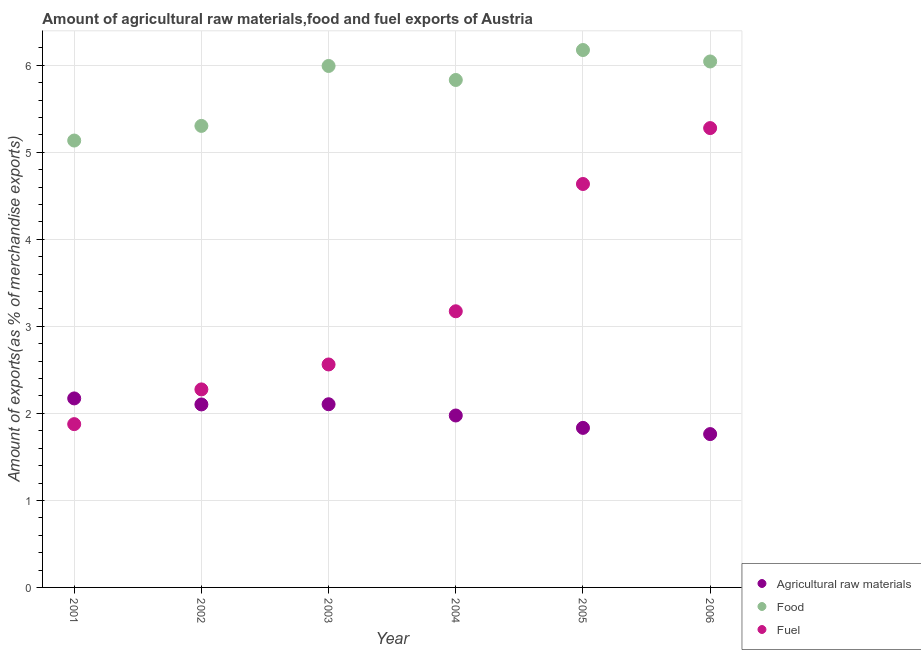Is the number of dotlines equal to the number of legend labels?
Keep it short and to the point. Yes. What is the percentage of fuel exports in 2002?
Your answer should be compact. 2.28. Across all years, what is the maximum percentage of fuel exports?
Keep it short and to the point. 5.28. Across all years, what is the minimum percentage of fuel exports?
Keep it short and to the point. 1.88. In which year was the percentage of raw materials exports maximum?
Ensure brevity in your answer.  2001. In which year was the percentage of fuel exports minimum?
Provide a succinct answer. 2001. What is the total percentage of food exports in the graph?
Your response must be concise. 34.48. What is the difference between the percentage of fuel exports in 2001 and that in 2003?
Your response must be concise. -0.69. What is the difference between the percentage of raw materials exports in 2005 and the percentage of food exports in 2004?
Provide a succinct answer. -4. What is the average percentage of fuel exports per year?
Offer a very short reply. 3.3. In the year 2003, what is the difference between the percentage of fuel exports and percentage of raw materials exports?
Make the answer very short. 0.46. In how many years, is the percentage of food exports greater than 0.4 %?
Ensure brevity in your answer.  6. What is the ratio of the percentage of raw materials exports in 2003 to that in 2004?
Offer a terse response. 1.07. What is the difference between the highest and the second highest percentage of raw materials exports?
Provide a short and direct response. 0.07. What is the difference between the highest and the lowest percentage of food exports?
Give a very brief answer. 1.04. Is it the case that in every year, the sum of the percentage of raw materials exports and percentage of food exports is greater than the percentage of fuel exports?
Your response must be concise. Yes. Is the percentage of food exports strictly greater than the percentage of fuel exports over the years?
Your answer should be very brief. Yes. How many dotlines are there?
Ensure brevity in your answer.  3. How many years are there in the graph?
Your answer should be very brief. 6. Are the values on the major ticks of Y-axis written in scientific E-notation?
Make the answer very short. No. Does the graph contain any zero values?
Ensure brevity in your answer.  No. Does the graph contain grids?
Provide a succinct answer. Yes. Where does the legend appear in the graph?
Make the answer very short. Bottom right. What is the title of the graph?
Offer a terse response. Amount of agricultural raw materials,food and fuel exports of Austria. What is the label or title of the X-axis?
Your answer should be very brief. Year. What is the label or title of the Y-axis?
Ensure brevity in your answer.  Amount of exports(as % of merchandise exports). What is the Amount of exports(as % of merchandise exports) in Agricultural raw materials in 2001?
Your answer should be very brief. 2.17. What is the Amount of exports(as % of merchandise exports) in Food in 2001?
Offer a very short reply. 5.14. What is the Amount of exports(as % of merchandise exports) in Fuel in 2001?
Your answer should be compact. 1.88. What is the Amount of exports(as % of merchandise exports) of Agricultural raw materials in 2002?
Offer a terse response. 2.1. What is the Amount of exports(as % of merchandise exports) of Food in 2002?
Your answer should be compact. 5.3. What is the Amount of exports(as % of merchandise exports) in Fuel in 2002?
Provide a succinct answer. 2.28. What is the Amount of exports(as % of merchandise exports) of Agricultural raw materials in 2003?
Your answer should be very brief. 2.11. What is the Amount of exports(as % of merchandise exports) in Food in 2003?
Provide a short and direct response. 5.99. What is the Amount of exports(as % of merchandise exports) in Fuel in 2003?
Ensure brevity in your answer.  2.56. What is the Amount of exports(as % of merchandise exports) in Agricultural raw materials in 2004?
Your answer should be very brief. 1.98. What is the Amount of exports(as % of merchandise exports) in Food in 2004?
Your answer should be very brief. 5.83. What is the Amount of exports(as % of merchandise exports) of Fuel in 2004?
Offer a very short reply. 3.17. What is the Amount of exports(as % of merchandise exports) of Agricultural raw materials in 2005?
Offer a very short reply. 1.83. What is the Amount of exports(as % of merchandise exports) in Food in 2005?
Your answer should be very brief. 6.18. What is the Amount of exports(as % of merchandise exports) of Fuel in 2005?
Provide a short and direct response. 4.64. What is the Amount of exports(as % of merchandise exports) of Agricultural raw materials in 2006?
Offer a terse response. 1.76. What is the Amount of exports(as % of merchandise exports) in Food in 2006?
Provide a short and direct response. 6.04. What is the Amount of exports(as % of merchandise exports) in Fuel in 2006?
Offer a very short reply. 5.28. Across all years, what is the maximum Amount of exports(as % of merchandise exports) in Agricultural raw materials?
Ensure brevity in your answer.  2.17. Across all years, what is the maximum Amount of exports(as % of merchandise exports) in Food?
Give a very brief answer. 6.18. Across all years, what is the maximum Amount of exports(as % of merchandise exports) of Fuel?
Ensure brevity in your answer.  5.28. Across all years, what is the minimum Amount of exports(as % of merchandise exports) of Agricultural raw materials?
Your response must be concise. 1.76. Across all years, what is the minimum Amount of exports(as % of merchandise exports) in Food?
Provide a succinct answer. 5.14. Across all years, what is the minimum Amount of exports(as % of merchandise exports) in Fuel?
Ensure brevity in your answer.  1.88. What is the total Amount of exports(as % of merchandise exports) of Agricultural raw materials in the graph?
Offer a terse response. 11.95. What is the total Amount of exports(as % of merchandise exports) of Food in the graph?
Ensure brevity in your answer.  34.48. What is the total Amount of exports(as % of merchandise exports) of Fuel in the graph?
Offer a very short reply. 19.8. What is the difference between the Amount of exports(as % of merchandise exports) in Agricultural raw materials in 2001 and that in 2002?
Your answer should be very brief. 0.07. What is the difference between the Amount of exports(as % of merchandise exports) in Food in 2001 and that in 2002?
Provide a succinct answer. -0.17. What is the difference between the Amount of exports(as % of merchandise exports) of Fuel in 2001 and that in 2002?
Provide a succinct answer. -0.4. What is the difference between the Amount of exports(as % of merchandise exports) in Agricultural raw materials in 2001 and that in 2003?
Provide a succinct answer. 0.07. What is the difference between the Amount of exports(as % of merchandise exports) in Food in 2001 and that in 2003?
Your answer should be very brief. -0.86. What is the difference between the Amount of exports(as % of merchandise exports) of Fuel in 2001 and that in 2003?
Your response must be concise. -0.69. What is the difference between the Amount of exports(as % of merchandise exports) of Agricultural raw materials in 2001 and that in 2004?
Give a very brief answer. 0.2. What is the difference between the Amount of exports(as % of merchandise exports) of Food in 2001 and that in 2004?
Offer a very short reply. -0.7. What is the difference between the Amount of exports(as % of merchandise exports) in Fuel in 2001 and that in 2004?
Your answer should be compact. -1.3. What is the difference between the Amount of exports(as % of merchandise exports) in Agricultural raw materials in 2001 and that in 2005?
Your answer should be very brief. 0.34. What is the difference between the Amount of exports(as % of merchandise exports) of Food in 2001 and that in 2005?
Make the answer very short. -1.04. What is the difference between the Amount of exports(as % of merchandise exports) in Fuel in 2001 and that in 2005?
Offer a very short reply. -2.76. What is the difference between the Amount of exports(as % of merchandise exports) in Agricultural raw materials in 2001 and that in 2006?
Keep it short and to the point. 0.41. What is the difference between the Amount of exports(as % of merchandise exports) of Food in 2001 and that in 2006?
Your answer should be very brief. -0.91. What is the difference between the Amount of exports(as % of merchandise exports) in Fuel in 2001 and that in 2006?
Provide a short and direct response. -3.4. What is the difference between the Amount of exports(as % of merchandise exports) of Agricultural raw materials in 2002 and that in 2003?
Provide a succinct answer. -0. What is the difference between the Amount of exports(as % of merchandise exports) in Food in 2002 and that in 2003?
Make the answer very short. -0.69. What is the difference between the Amount of exports(as % of merchandise exports) in Fuel in 2002 and that in 2003?
Offer a terse response. -0.29. What is the difference between the Amount of exports(as % of merchandise exports) of Agricultural raw materials in 2002 and that in 2004?
Keep it short and to the point. 0.13. What is the difference between the Amount of exports(as % of merchandise exports) in Food in 2002 and that in 2004?
Provide a succinct answer. -0.53. What is the difference between the Amount of exports(as % of merchandise exports) of Fuel in 2002 and that in 2004?
Ensure brevity in your answer.  -0.9. What is the difference between the Amount of exports(as % of merchandise exports) in Agricultural raw materials in 2002 and that in 2005?
Give a very brief answer. 0.27. What is the difference between the Amount of exports(as % of merchandise exports) in Food in 2002 and that in 2005?
Your answer should be compact. -0.87. What is the difference between the Amount of exports(as % of merchandise exports) in Fuel in 2002 and that in 2005?
Your response must be concise. -2.36. What is the difference between the Amount of exports(as % of merchandise exports) in Agricultural raw materials in 2002 and that in 2006?
Your answer should be very brief. 0.34. What is the difference between the Amount of exports(as % of merchandise exports) in Food in 2002 and that in 2006?
Your answer should be very brief. -0.74. What is the difference between the Amount of exports(as % of merchandise exports) of Fuel in 2002 and that in 2006?
Provide a succinct answer. -3. What is the difference between the Amount of exports(as % of merchandise exports) of Agricultural raw materials in 2003 and that in 2004?
Offer a very short reply. 0.13. What is the difference between the Amount of exports(as % of merchandise exports) of Food in 2003 and that in 2004?
Offer a terse response. 0.16. What is the difference between the Amount of exports(as % of merchandise exports) of Fuel in 2003 and that in 2004?
Offer a terse response. -0.61. What is the difference between the Amount of exports(as % of merchandise exports) of Agricultural raw materials in 2003 and that in 2005?
Ensure brevity in your answer.  0.27. What is the difference between the Amount of exports(as % of merchandise exports) in Food in 2003 and that in 2005?
Your response must be concise. -0.18. What is the difference between the Amount of exports(as % of merchandise exports) in Fuel in 2003 and that in 2005?
Keep it short and to the point. -2.07. What is the difference between the Amount of exports(as % of merchandise exports) in Agricultural raw materials in 2003 and that in 2006?
Provide a succinct answer. 0.34. What is the difference between the Amount of exports(as % of merchandise exports) of Food in 2003 and that in 2006?
Keep it short and to the point. -0.05. What is the difference between the Amount of exports(as % of merchandise exports) of Fuel in 2003 and that in 2006?
Keep it short and to the point. -2.72. What is the difference between the Amount of exports(as % of merchandise exports) in Agricultural raw materials in 2004 and that in 2005?
Make the answer very short. 0.14. What is the difference between the Amount of exports(as % of merchandise exports) in Food in 2004 and that in 2005?
Your response must be concise. -0.34. What is the difference between the Amount of exports(as % of merchandise exports) in Fuel in 2004 and that in 2005?
Ensure brevity in your answer.  -1.46. What is the difference between the Amount of exports(as % of merchandise exports) in Agricultural raw materials in 2004 and that in 2006?
Your answer should be very brief. 0.21. What is the difference between the Amount of exports(as % of merchandise exports) in Food in 2004 and that in 2006?
Provide a succinct answer. -0.21. What is the difference between the Amount of exports(as % of merchandise exports) of Fuel in 2004 and that in 2006?
Your answer should be very brief. -2.11. What is the difference between the Amount of exports(as % of merchandise exports) of Agricultural raw materials in 2005 and that in 2006?
Provide a short and direct response. 0.07. What is the difference between the Amount of exports(as % of merchandise exports) of Food in 2005 and that in 2006?
Keep it short and to the point. 0.13. What is the difference between the Amount of exports(as % of merchandise exports) in Fuel in 2005 and that in 2006?
Offer a terse response. -0.64. What is the difference between the Amount of exports(as % of merchandise exports) of Agricultural raw materials in 2001 and the Amount of exports(as % of merchandise exports) of Food in 2002?
Provide a short and direct response. -3.13. What is the difference between the Amount of exports(as % of merchandise exports) in Agricultural raw materials in 2001 and the Amount of exports(as % of merchandise exports) in Fuel in 2002?
Offer a very short reply. -0.1. What is the difference between the Amount of exports(as % of merchandise exports) of Food in 2001 and the Amount of exports(as % of merchandise exports) of Fuel in 2002?
Your answer should be very brief. 2.86. What is the difference between the Amount of exports(as % of merchandise exports) of Agricultural raw materials in 2001 and the Amount of exports(as % of merchandise exports) of Food in 2003?
Make the answer very short. -3.82. What is the difference between the Amount of exports(as % of merchandise exports) in Agricultural raw materials in 2001 and the Amount of exports(as % of merchandise exports) in Fuel in 2003?
Keep it short and to the point. -0.39. What is the difference between the Amount of exports(as % of merchandise exports) of Food in 2001 and the Amount of exports(as % of merchandise exports) of Fuel in 2003?
Provide a succinct answer. 2.57. What is the difference between the Amount of exports(as % of merchandise exports) of Agricultural raw materials in 2001 and the Amount of exports(as % of merchandise exports) of Food in 2004?
Offer a terse response. -3.66. What is the difference between the Amount of exports(as % of merchandise exports) in Agricultural raw materials in 2001 and the Amount of exports(as % of merchandise exports) in Fuel in 2004?
Provide a short and direct response. -1. What is the difference between the Amount of exports(as % of merchandise exports) of Food in 2001 and the Amount of exports(as % of merchandise exports) of Fuel in 2004?
Give a very brief answer. 1.96. What is the difference between the Amount of exports(as % of merchandise exports) of Agricultural raw materials in 2001 and the Amount of exports(as % of merchandise exports) of Food in 2005?
Your answer should be very brief. -4. What is the difference between the Amount of exports(as % of merchandise exports) in Agricultural raw materials in 2001 and the Amount of exports(as % of merchandise exports) in Fuel in 2005?
Give a very brief answer. -2.46. What is the difference between the Amount of exports(as % of merchandise exports) of Food in 2001 and the Amount of exports(as % of merchandise exports) of Fuel in 2005?
Your answer should be compact. 0.5. What is the difference between the Amount of exports(as % of merchandise exports) of Agricultural raw materials in 2001 and the Amount of exports(as % of merchandise exports) of Food in 2006?
Your answer should be compact. -3.87. What is the difference between the Amount of exports(as % of merchandise exports) of Agricultural raw materials in 2001 and the Amount of exports(as % of merchandise exports) of Fuel in 2006?
Provide a succinct answer. -3.11. What is the difference between the Amount of exports(as % of merchandise exports) of Food in 2001 and the Amount of exports(as % of merchandise exports) of Fuel in 2006?
Offer a terse response. -0.14. What is the difference between the Amount of exports(as % of merchandise exports) of Agricultural raw materials in 2002 and the Amount of exports(as % of merchandise exports) of Food in 2003?
Your response must be concise. -3.89. What is the difference between the Amount of exports(as % of merchandise exports) in Agricultural raw materials in 2002 and the Amount of exports(as % of merchandise exports) in Fuel in 2003?
Provide a succinct answer. -0.46. What is the difference between the Amount of exports(as % of merchandise exports) in Food in 2002 and the Amount of exports(as % of merchandise exports) in Fuel in 2003?
Ensure brevity in your answer.  2.74. What is the difference between the Amount of exports(as % of merchandise exports) of Agricultural raw materials in 2002 and the Amount of exports(as % of merchandise exports) of Food in 2004?
Offer a very short reply. -3.73. What is the difference between the Amount of exports(as % of merchandise exports) of Agricultural raw materials in 2002 and the Amount of exports(as % of merchandise exports) of Fuel in 2004?
Offer a very short reply. -1.07. What is the difference between the Amount of exports(as % of merchandise exports) of Food in 2002 and the Amount of exports(as % of merchandise exports) of Fuel in 2004?
Keep it short and to the point. 2.13. What is the difference between the Amount of exports(as % of merchandise exports) in Agricultural raw materials in 2002 and the Amount of exports(as % of merchandise exports) in Food in 2005?
Ensure brevity in your answer.  -4.07. What is the difference between the Amount of exports(as % of merchandise exports) of Agricultural raw materials in 2002 and the Amount of exports(as % of merchandise exports) of Fuel in 2005?
Ensure brevity in your answer.  -2.53. What is the difference between the Amount of exports(as % of merchandise exports) of Food in 2002 and the Amount of exports(as % of merchandise exports) of Fuel in 2005?
Offer a terse response. 0.67. What is the difference between the Amount of exports(as % of merchandise exports) of Agricultural raw materials in 2002 and the Amount of exports(as % of merchandise exports) of Food in 2006?
Provide a succinct answer. -3.94. What is the difference between the Amount of exports(as % of merchandise exports) of Agricultural raw materials in 2002 and the Amount of exports(as % of merchandise exports) of Fuel in 2006?
Provide a short and direct response. -3.18. What is the difference between the Amount of exports(as % of merchandise exports) of Food in 2002 and the Amount of exports(as % of merchandise exports) of Fuel in 2006?
Offer a very short reply. 0.03. What is the difference between the Amount of exports(as % of merchandise exports) in Agricultural raw materials in 2003 and the Amount of exports(as % of merchandise exports) in Food in 2004?
Make the answer very short. -3.73. What is the difference between the Amount of exports(as % of merchandise exports) of Agricultural raw materials in 2003 and the Amount of exports(as % of merchandise exports) of Fuel in 2004?
Your answer should be compact. -1.07. What is the difference between the Amount of exports(as % of merchandise exports) of Food in 2003 and the Amount of exports(as % of merchandise exports) of Fuel in 2004?
Ensure brevity in your answer.  2.82. What is the difference between the Amount of exports(as % of merchandise exports) of Agricultural raw materials in 2003 and the Amount of exports(as % of merchandise exports) of Food in 2005?
Keep it short and to the point. -4.07. What is the difference between the Amount of exports(as % of merchandise exports) of Agricultural raw materials in 2003 and the Amount of exports(as % of merchandise exports) of Fuel in 2005?
Your answer should be compact. -2.53. What is the difference between the Amount of exports(as % of merchandise exports) of Food in 2003 and the Amount of exports(as % of merchandise exports) of Fuel in 2005?
Your answer should be compact. 1.36. What is the difference between the Amount of exports(as % of merchandise exports) in Agricultural raw materials in 2003 and the Amount of exports(as % of merchandise exports) in Food in 2006?
Provide a short and direct response. -3.94. What is the difference between the Amount of exports(as % of merchandise exports) of Agricultural raw materials in 2003 and the Amount of exports(as % of merchandise exports) of Fuel in 2006?
Your answer should be very brief. -3.17. What is the difference between the Amount of exports(as % of merchandise exports) in Food in 2003 and the Amount of exports(as % of merchandise exports) in Fuel in 2006?
Your answer should be very brief. 0.71. What is the difference between the Amount of exports(as % of merchandise exports) in Agricultural raw materials in 2004 and the Amount of exports(as % of merchandise exports) in Food in 2005?
Your response must be concise. -4.2. What is the difference between the Amount of exports(as % of merchandise exports) in Agricultural raw materials in 2004 and the Amount of exports(as % of merchandise exports) in Fuel in 2005?
Provide a short and direct response. -2.66. What is the difference between the Amount of exports(as % of merchandise exports) in Food in 2004 and the Amount of exports(as % of merchandise exports) in Fuel in 2005?
Make the answer very short. 1.2. What is the difference between the Amount of exports(as % of merchandise exports) of Agricultural raw materials in 2004 and the Amount of exports(as % of merchandise exports) of Food in 2006?
Make the answer very short. -4.07. What is the difference between the Amount of exports(as % of merchandise exports) of Agricultural raw materials in 2004 and the Amount of exports(as % of merchandise exports) of Fuel in 2006?
Ensure brevity in your answer.  -3.3. What is the difference between the Amount of exports(as % of merchandise exports) of Food in 2004 and the Amount of exports(as % of merchandise exports) of Fuel in 2006?
Give a very brief answer. 0.55. What is the difference between the Amount of exports(as % of merchandise exports) of Agricultural raw materials in 2005 and the Amount of exports(as % of merchandise exports) of Food in 2006?
Give a very brief answer. -4.21. What is the difference between the Amount of exports(as % of merchandise exports) in Agricultural raw materials in 2005 and the Amount of exports(as % of merchandise exports) in Fuel in 2006?
Give a very brief answer. -3.45. What is the difference between the Amount of exports(as % of merchandise exports) of Food in 2005 and the Amount of exports(as % of merchandise exports) of Fuel in 2006?
Give a very brief answer. 0.9. What is the average Amount of exports(as % of merchandise exports) of Agricultural raw materials per year?
Offer a very short reply. 1.99. What is the average Amount of exports(as % of merchandise exports) of Food per year?
Your answer should be compact. 5.75. What is the average Amount of exports(as % of merchandise exports) in Fuel per year?
Offer a very short reply. 3.3. In the year 2001, what is the difference between the Amount of exports(as % of merchandise exports) of Agricultural raw materials and Amount of exports(as % of merchandise exports) of Food?
Make the answer very short. -2.96. In the year 2001, what is the difference between the Amount of exports(as % of merchandise exports) in Agricultural raw materials and Amount of exports(as % of merchandise exports) in Fuel?
Your answer should be compact. 0.3. In the year 2001, what is the difference between the Amount of exports(as % of merchandise exports) in Food and Amount of exports(as % of merchandise exports) in Fuel?
Your answer should be compact. 3.26. In the year 2002, what is the difference between the Amount of exports(as % of merchandise exports) of Agricultural raw materials and Amount of exports(as % of merchandise exports) of Food?
Provide a succinct answer. -3.2. In the year 2002, what is the difference between the Amount of exports(as % of merchandise exports) in Agricultural raw materials and Amount of exports(as % of merchandise exports) in Fuel?
Give a very brief answer. -0.17. In the year 2002, what is the difference between the Amount of exports(as % of merchandise exports) of Food and Amount of exports(as % of merchandise exports) of Fuel?
Make the answer very short. 3.03. In the year 2003, what is the difference between the Amount of exports(as % of merchandise exports) of Agricultural raw materials and Amount of exports(as % of merchandise exports) of Food?
Offer a terse response. -3.89. In the year 2003, what is the difference between the Amount of exports(as % of merchandise exports) in Agricultural raw materials and Amount of exports(as % of merchandise exports) in Fuel?
Keep it short and to the point. -0.46. In the year 2003, what is the difference between the Amount of exports(as % of merchandise exports) of Food and Amount of exports(as % of merchandise exports) of Fuel?
Provide a short and direct response. 3.43. In the year 2004, what is the difference between the Amount of exports(as % of merchandise exports) in Agricultural raw materials and Amount of exports(as % of merchandise exports) in Food?
Ensure brevity in your answer.  -3.86. In the year 2004, what is the difference between the Amount of exports(as % of merchandise exports) of Agricultural raw materials and Amount of exports(as % of merchandise exports) of Fuel?
Your response must be concise. -1.2. In the year 2004, what is the difference between the Amount of exports(as % of merchandise exports) in Food and Amount of exports(as % of merchandise exports) in Fuel?
Your answer should be very brief. 2.66. In the year 2005, what is the difference between the Amount of exports(as % of merchandise exports) in Agricultural raw materials and Amount of exports(as % of merchandise exports) in Food?
Provide a succinct answer. -4.34. In the year 2005, what is the difference between the Amount of exports(as % of merchandise exports) of Agricultural raw materials and Amount of exports(as % of merchandise exports) of Fuel?
Your answer should be very brief. -2.8. In the year 2005, what is the difference between the Amount of exports(as % of merchandise exports) in Food and Amount of exports(as % of merchandise exports) in Fuel?
Ensure brevity in your answer.  1.54. In the year 2006, what is the difference between the Amount of exports(as % of merchandise exports) in Agricultural raw materials and Amount of exports(as % of merchandise exports) in Food?
Ensure brevity in your answer.  -4.28. In the year 2006, what is the difference between the Amount of exports(as % of merchandise exports) of Agricultural raw materials and Amount of exports(as % of merchandise exports) of Fuel?
Make the answer very short. -3.52. In the year 2006, what is the difference between the Amount of exports(as % of merchandise exports) of Food and Amount of exports(as % of merchandise exports) of Fuel?
Your response must be concise. 0.77. What is the ratio of the Amount of exports(as % of merchandise exports) of Agricultural raw materials in 2001 to that in 2002?
Offer a very short reply. 1.03. What is the ratio of the Amount of exports(as % of merchandise exports) in Food in 2001 to that in 2002?
Your answer should be compact. 0.97. What is the ratio of the Amount of exports(as % of merchandise exports) in Fuel in 2001 to that in 2002?
Your answer should be very brief. 0.82. What is the ratio of the Amount of exports(as % of merchandise exports) of Agricultural raw materials in 2001 to that in 2003?
Your answer should be very brief. 1.03. What is the ratio of the Amount of exports(as % of merchandise exports) in Food in 2001 to that in 2003?
Provide a succinct answer. 0.86. What is the ratio of the Amount of exports(as % of merchandise exports) in Fuel in 2001 to that in 2003?
Make the answer very short. 0.73. What is the ratio of the Amount of exports(as % of merchandise exports) in Agricultural raw materials in 2001 to that in 2004?
Ensure brevity in your answer.  1.1. What is the ratio of the Amount of exports(as % of merchandise exports) of Food in 2001 to that in 2004?
Provide a short and direct response. 0.88. What is the ratio of the Amount of exports(as % of merchandise exports) in Fuel in 2001 to that in 2004?
Offer a terse response. 0.59. What is the ratio of the Amount of exports(as % of merchandise exports) of Agricultural raw materials in 2001 to that in 2005?
Offer a very short reply. 1.18. What is the ratio of the Amount of exports(as % of merchandise exports) of Food in 2001 to that in 2005?
Offer a terse response. 0.83. What is the ratio of the Amount of exports(as % of merchandise exports) in Fuel in 2001 to that in 2005?
Your response must be concise. 0.4. What is the ratio of the Amount of exports(as % of merchandise exports) in Agricultural raw materials in 2001 to that in 2006?
Your answer should be very brief. 1.23. What is the ratio of the Amount of exports(as % of merchandise exports) of Food in 2001 to that in 2006?
Your answer should be very brief. 0.85. What is the ratio of the Amount of exports(as % of merchandise exports) in Fuel in 2001 to that in 2006?
Your answer should be compact. 0.36. What is the ratio of the Amount of exports(as % of merchandise exports) of Food in 2002 to that in 2003?
Your answer should be very brief. 0.89. What is the ratio of the Amount of exports(as % of merchandise exports) in Fuel in 2002 to that in 2003?
Your answer should be compact. 0.89. What is the ratio of the Amount of exports(as % of merchandise exports) in Agricultural raw materials in 2002 to that in 2004?
Offer a terse response. 1.06. What is the ratio of the Amount of exports(as % of merchandise exports) of Food in 2002 to that in 2004?
Provide a short and direct response. 0.91. What is the ratio of the Amount of exports(as % of merchandise exports) in Fuel in 2002 to that in 2004?
Your response must be concise. 0.72. What is the ratio of the Amount of exports(as % of merchandise exports) of Agricultural raw materials in 2002 to that in 2005?
Your response must be concise. 1.15. What is the ratio of the Amount of exports(as % of merchandise exports) of Food in 2002 to that in 2005?
Your answer should be compact. 0.86. What is the ratio of the Amount of exports(as % of merchandise exports) in Fuel in 2002 to that in 2005?
Offer a terse response. 0.49. What is the ratio of the Amount of exports(as % of merchandise exports) of Agricultural raw materials in 2002 to that in 2006?
Provide a short and direct response. 1.19. What is the ratio of the Amount of exports(as % of merchandise exports) of Food in 2002 to that in 2006?
Give a very brief answer. 0.88. What is the ratio of the Amount of exports(as % of merchandise exports) of Fuel in 2002 to that in 2006?
Offer a terse response. 0.43. What is the ratio of the Amount of exports(as % of merchandise exports) of Agricultural raw materials in 2003 to that in 2004?
Give a very brief answer. 1.07. What is the ratio of the Amount of exports(as % of merchandise exports) in Food in 2003 to that in 2004?
Your answer should be very brief. 1.03. What is the ratio of the Amount of exports(as % of merchandise exports) in Fuel in 2003 to that in 2004?
Offer a very short reply. 0.81. What is the ratio of the Amount of exports(as % of merchandise exports) of Agricultural raw materials in 2003 to that in 2005?
Provide a succinct answer. 1.15. What is the ratio of the Amount of exports(as % of merchandise exports) in Food in 2003 to that in 2005?
Give a very brief answer. 0.97. What is the ratio of the Amount of exports(as % of merchandise exports) of Fuel in 2003 to that in 2005?
Offer a terse response. 0.55. What is the ratio of the Amount of exports(as % of merchandise exports) of Agricultural raw materials in 2003 to that in 2006?
Ensure brevity in your answer.  1.19. What is the ratio of the Amount of exports(as % of merchandise exports) of Food in 2003 to that in 2006?
Offer a terse response. 0.99. What is the ratio of the Amount of exports(as % of merchandise exports) in Fuel in 2003 to that in 2006?
Your answer should be very brief. 0.49. What is the ratio of the Amount of exports(as % of merchandise exports) in Agricultural raw materials in 2004 to that in 2005?
Make the answer very short. 1.08. What is the ratio of the Amount of exports(as % of merchandise exports) in Food in 2004 to that in 2005?
Offer a terse response. 0.94. What is the ratio of the Amount of exports(as % of merchandise exports) in Fuel in 2004 to that in 2005?
Give a very brief answer. 0.68. What is the ratio of the Amount of exports(as % of merchandise exports) of Agricultural raw materials in 2004 to that in 2006?
Your answer should be very brief. 1.12. What is the ratio of the Amount of exports(as % of merchandise exports) of Food in 2004 to that in 2006?
Keep it short and to the point. 0.96. What is the ratio of the Amount of exports(as % of merchandise exports) of Fuel in 2004 to that in 2006?
Give a very brief answer. 0.6. What is the ratio of the Amount of exports(as % of merchandise exports) of Agricultural raw materials in 2005 to that in 2006?
Make the answer very short. 1.04. What is the ratio of the Amount of exports(as % of merchandise exports) in Food in 2005 to that in 2006?
Your response must be concise. 1.02. What is the ratio of the Amount of exports(as % of merchandise exports) in Fuel in 2005 to that in 2006?
Offer a very short reply. 0.88. What is the difference between the highest and the second highest Amount of exports(as % of merchandise exports) in Agricultural raw materials?
Ensure brevity in your answer.  0.07. What is the difference between the highest and the second highest Amount of exports(as % of merchandise exports) in Food?
Keep it short and to the point. 0.13. What is the difference between the highest and the second highest Amount of exports(as % of merchandise exports) of Fuel?
Offer a terse response. 0.64. What is the difference between the highest and the lowest Amount of exports(as % of merchandise exports) of Agricultural raw materials?
Provide a short and direct response. 0.41. What is the difference between the highest and the lowest Amount of exports(as % of merchandise exports) of Food?
Offer a very short reply. 1.04. What is the difference between the highest and the lowest Amount of exports(as % of merchandise exports) of Fuel?
Your answer should be compact. 3.4. 